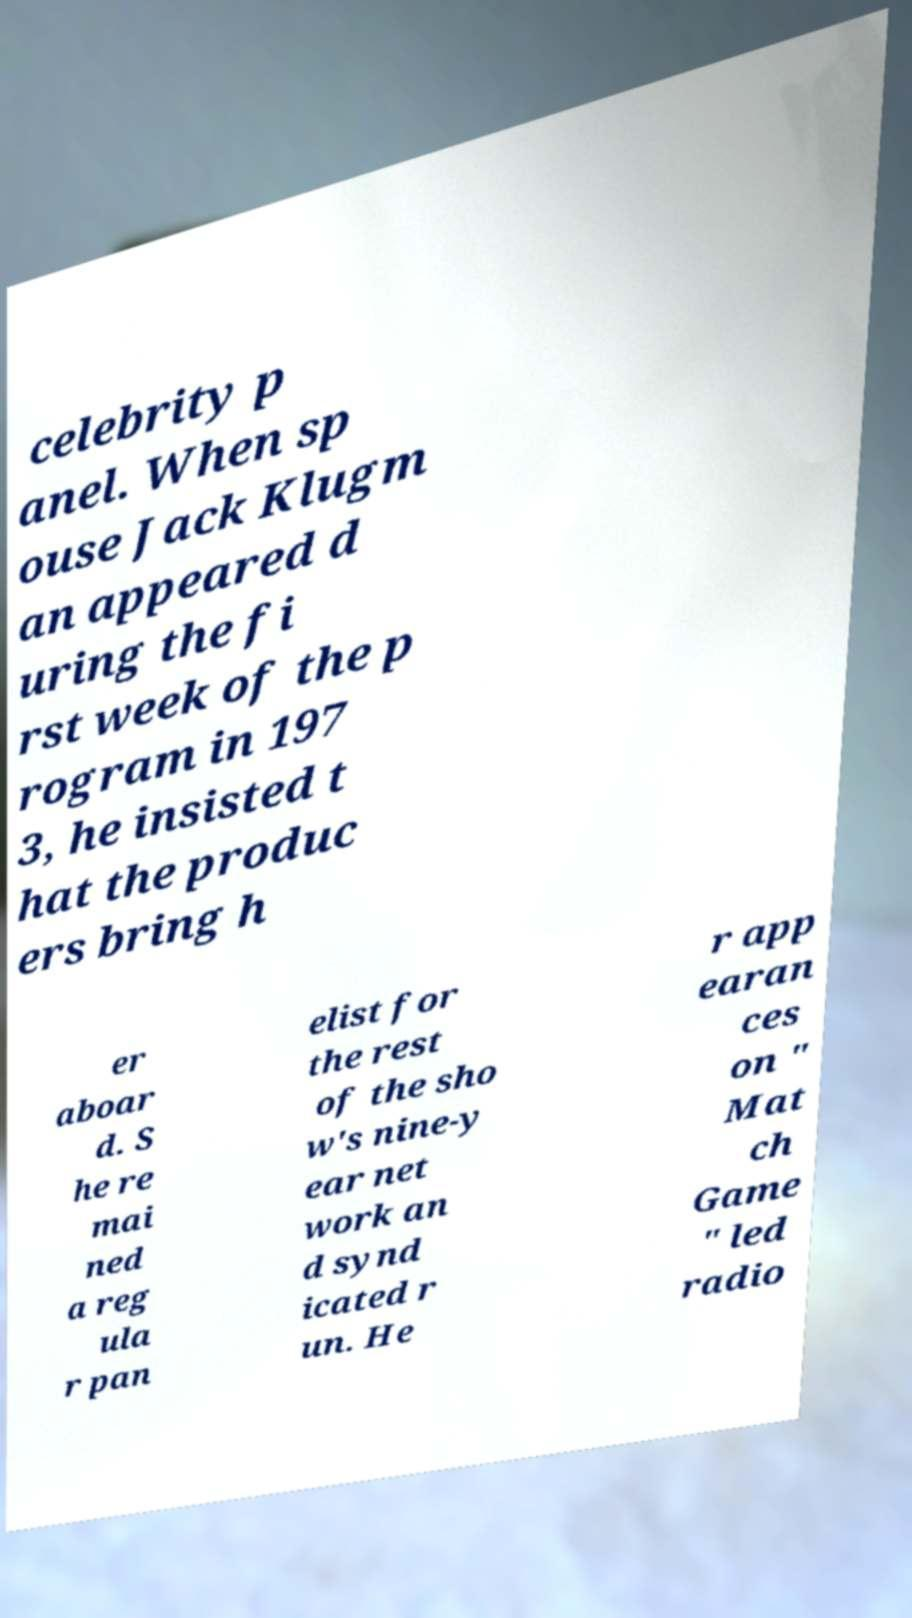Can you read and provide the text displayed in the image?This photo seems to have some interesting text. Can you extract and type it out for me? celebrity p anel. When sp ouse Jack Klugm an appeared d uring the fi rst week of the p rogram in 197 3, he insisted t hat the produc ers bring h er aboar d. S he re mai ned a reg ula r pan elist for the rest of the sho w's nine-y ear net work an d synd icated r un. He r app earan ces on " Mat ch Game " led radio 